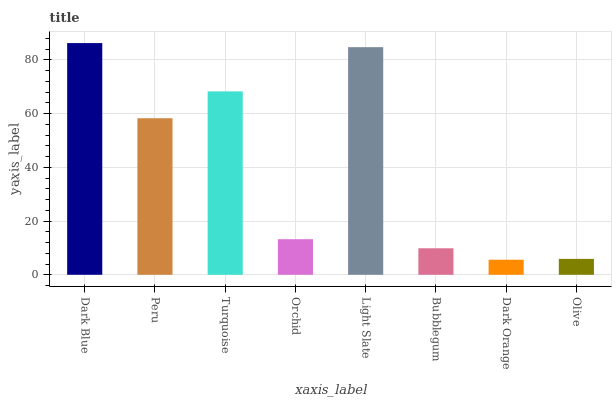Is Dark Orange the minimum?
Answer yes or no. Yes. Is Dark Blue the maximum?
Answer yes or no. Yes. Is Peru the minimum?
Answer yes or no. No. Is Peru the maximum?
Answer yes or no. No. Is Dark Blue greater than Peru?
Answer yes or no. Yes. Is Peru less than Dark Blue?
Answer yes or no. Yes. Is Peru greater than Dark Blue?
Answer yes or no. No. Is Dark Blue less than Peru?
Answer yes or no. No. Is Peru the high median?
Answer yes or no. Yes. Is Orchid the low median?
Answer yes or no. Yes. Is Turquoise the high median?
Answer yes or no. No. Is Bubblegum the low median?
Answer yes or no. No. 